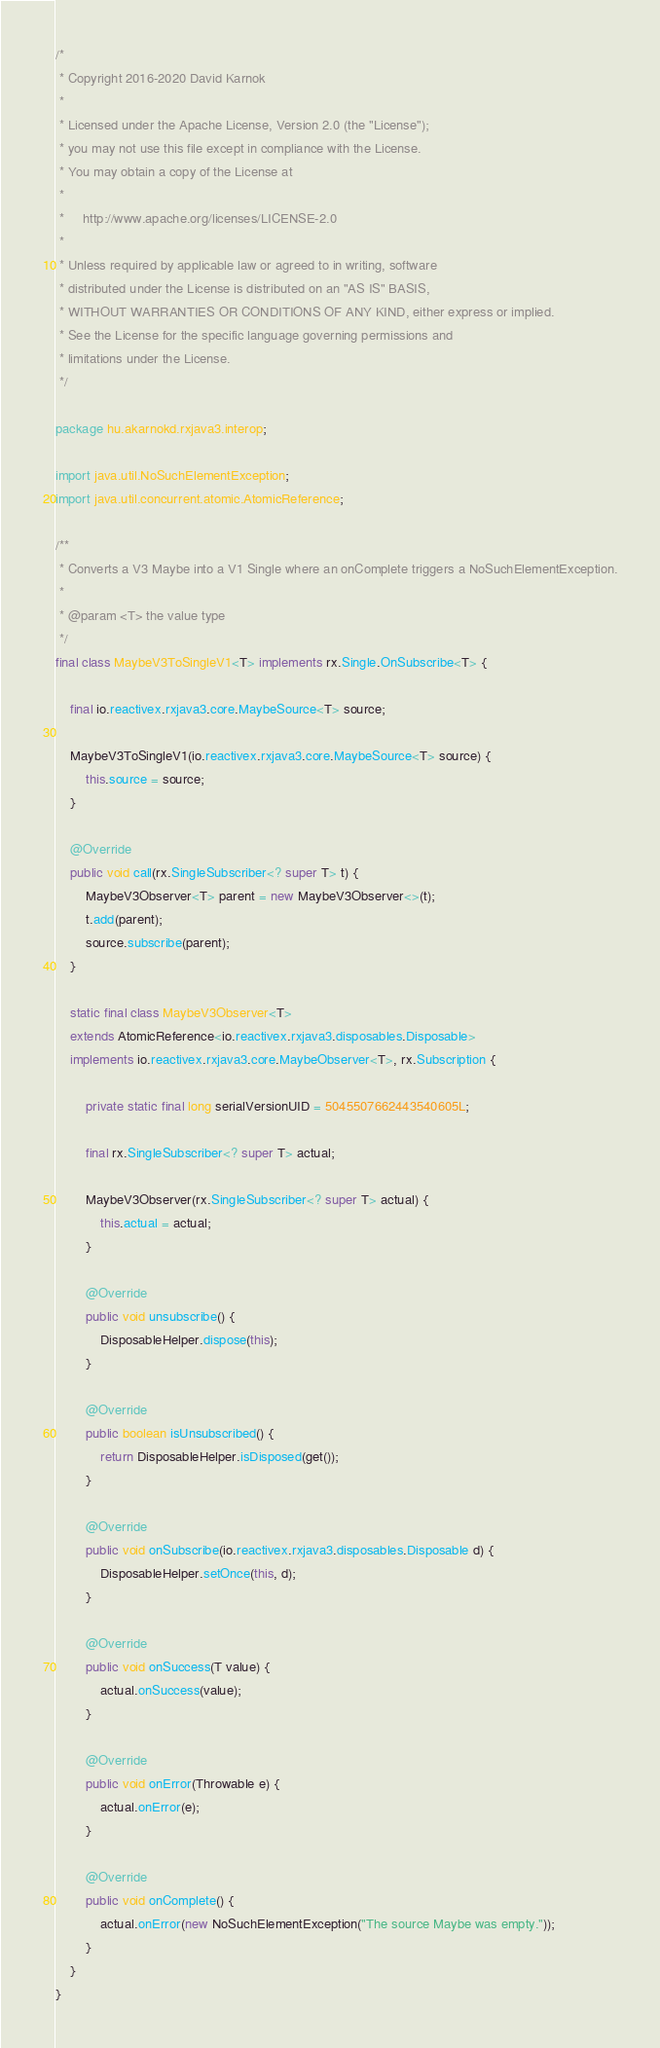<code> <loc_0><loc_0><loc_500><loc_500><_Java_>/*
 * Copyright 2016-2020 David Karnok
 *
 * Licensed under the Apache License, Version 2.0 (the "License");
 * you may not use this file except in compliance with the License.
 * You may obtain a copy of the License at
 *
 *     http://www.apache.org/licenses/LICENSE-2.0
 *
 * Unless required by applicable law or agreed to in writing, software
 * distributed under the License is distributed on an "AS IS" BASIS,
 * WITHOUT WARRANTIES OR CONDITIONS OF ANY KIND, either express or implied.
 * See the License for the specific language governing permissions and
 * limitations under the License.
 */

package hu.akarnokd.rxjava3.interop;

import java.util.NoSuchElementException;
import java.util.concurrent.atomic.AtomicReference;

/**
 * Converts a V3 Maybe into a V1 Single where an onComplete triggers a NoSuchElementException.
 *
 * @param <T> the value type
 */
final class MaybeV3ToSingleV1<T> implements rx.Single.OnSubscribe<T> {

    final io.reactivex.rxjava3.core.MaybeSource<T> source;

    MaybeV3ToSingleV1(io.reactivex.rxjava3.core.MaybeSource<T> source) {
        this.source = source;
    }

    @Override
    public void call(rx.SingleSubscriber<? super T> t) {
        MaybeV3Observer<T> parent = new MaybeV3Observer<>(t);
        t.add(parent);
        source.subscribe(parent);
    }

    static final class MaybeV3Observer<T>
    extends AtomicReference<io.reactivex.rxjava3.disposables.Disposable>
    implements io.reactivex.rxjava3.core.MaybeObserver<T>, rx.Subscription {

        private static final long serialVersionUID = 5045507662443540605L;

        final rx.SingleSubscriber<? super T> actual;

        MaybeV3Observer(rx.SingleSubscriber<? super T> actual) {
            this.actual = actual;
        }

        @Override
        public void unsubscribe() {
            DisposableHelper.dispose(this);
        }

        @Override
        public boolean isUnsubscribed() {
            return DisposableHelper.isDisposed(get());
        }

        @Override
        public void onSubscribe(io.reactivex.rxjava3.disposables.Disposable d) {
            DisposableHelper.setOnce(this, d);
        }

        @Override
        public void onSuccess(T value) {
            actual.onSuccess(value);
        }

        @Override
        public void onError(Throwable e) {
            actual.onError(e);
        }

        @Override
        public void onComplete() {
            actual.onError(new NoSuchElementException("The source Maybe was empty."));
        }
    }
}
</code> 